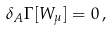<formula> <loc_0><loc_0><loc_500><loc_500>\delta _ { A } \Gamma [ W _ { \mu } ] = 0 \, ,</formula> 